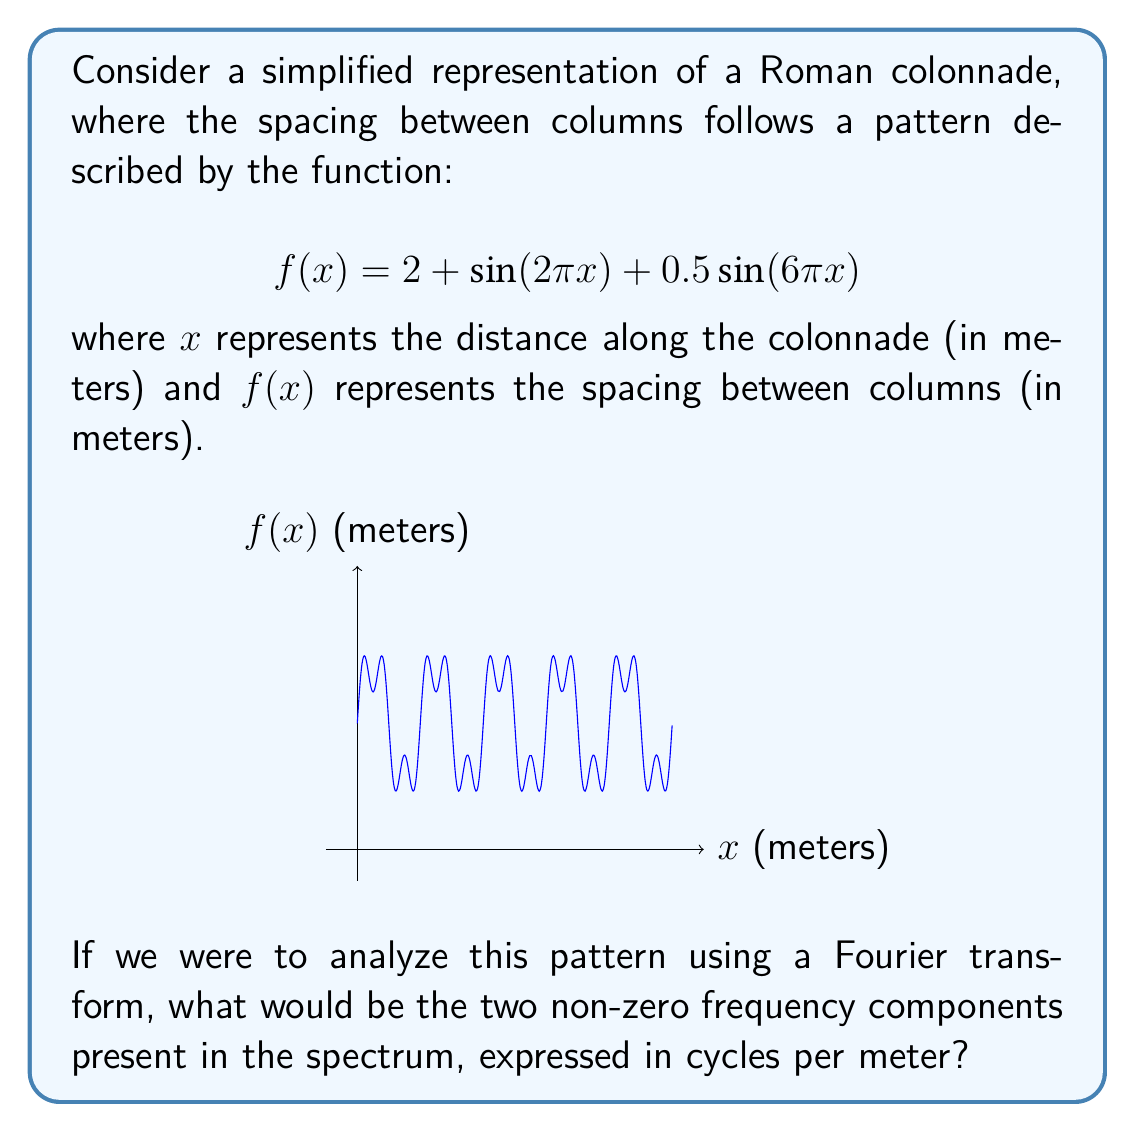Could you help me with this problem? Let's approach this step-by-step:

1) The Fourier transform decomposes a function into its constituent frequencies. In this case, our function is already expressed as a sum of sinusoids.

2) The general form of a sinusoid is $A\sin(2\pi fx)$, where $f$ is the frequency in cycles per unit of $x$.

3) In our function $f(x) = 2 + \sin(2\pi x) + 0.5\sin(6\pi x)$, we have two sinusoidal terms:

   a) $\sin(2\pi x)$
   b) $0.5\sin(6\pi x)$

4) For the first term, $\sin(2\pi x)$:
   Comparing to the general form, we see that $2\pi = 2\pi f$
   Therefore, $f = 1$ cycle per meter

5) For the second term, $0.5\sin(6\pi x)$:
   Comparing to the general form, we see that $6\pi = 2\pi f$
   Therefore, $f = 3$ cycles per meter

6) The constant term 2 corresponds to a frequency of 0, which is typically not considered in frequency analysis.

Thus, the two non-zero frequency components are 1 cycle per meter and 3 cycles per meter.
Answer: 1 and 3 cycles per meter 